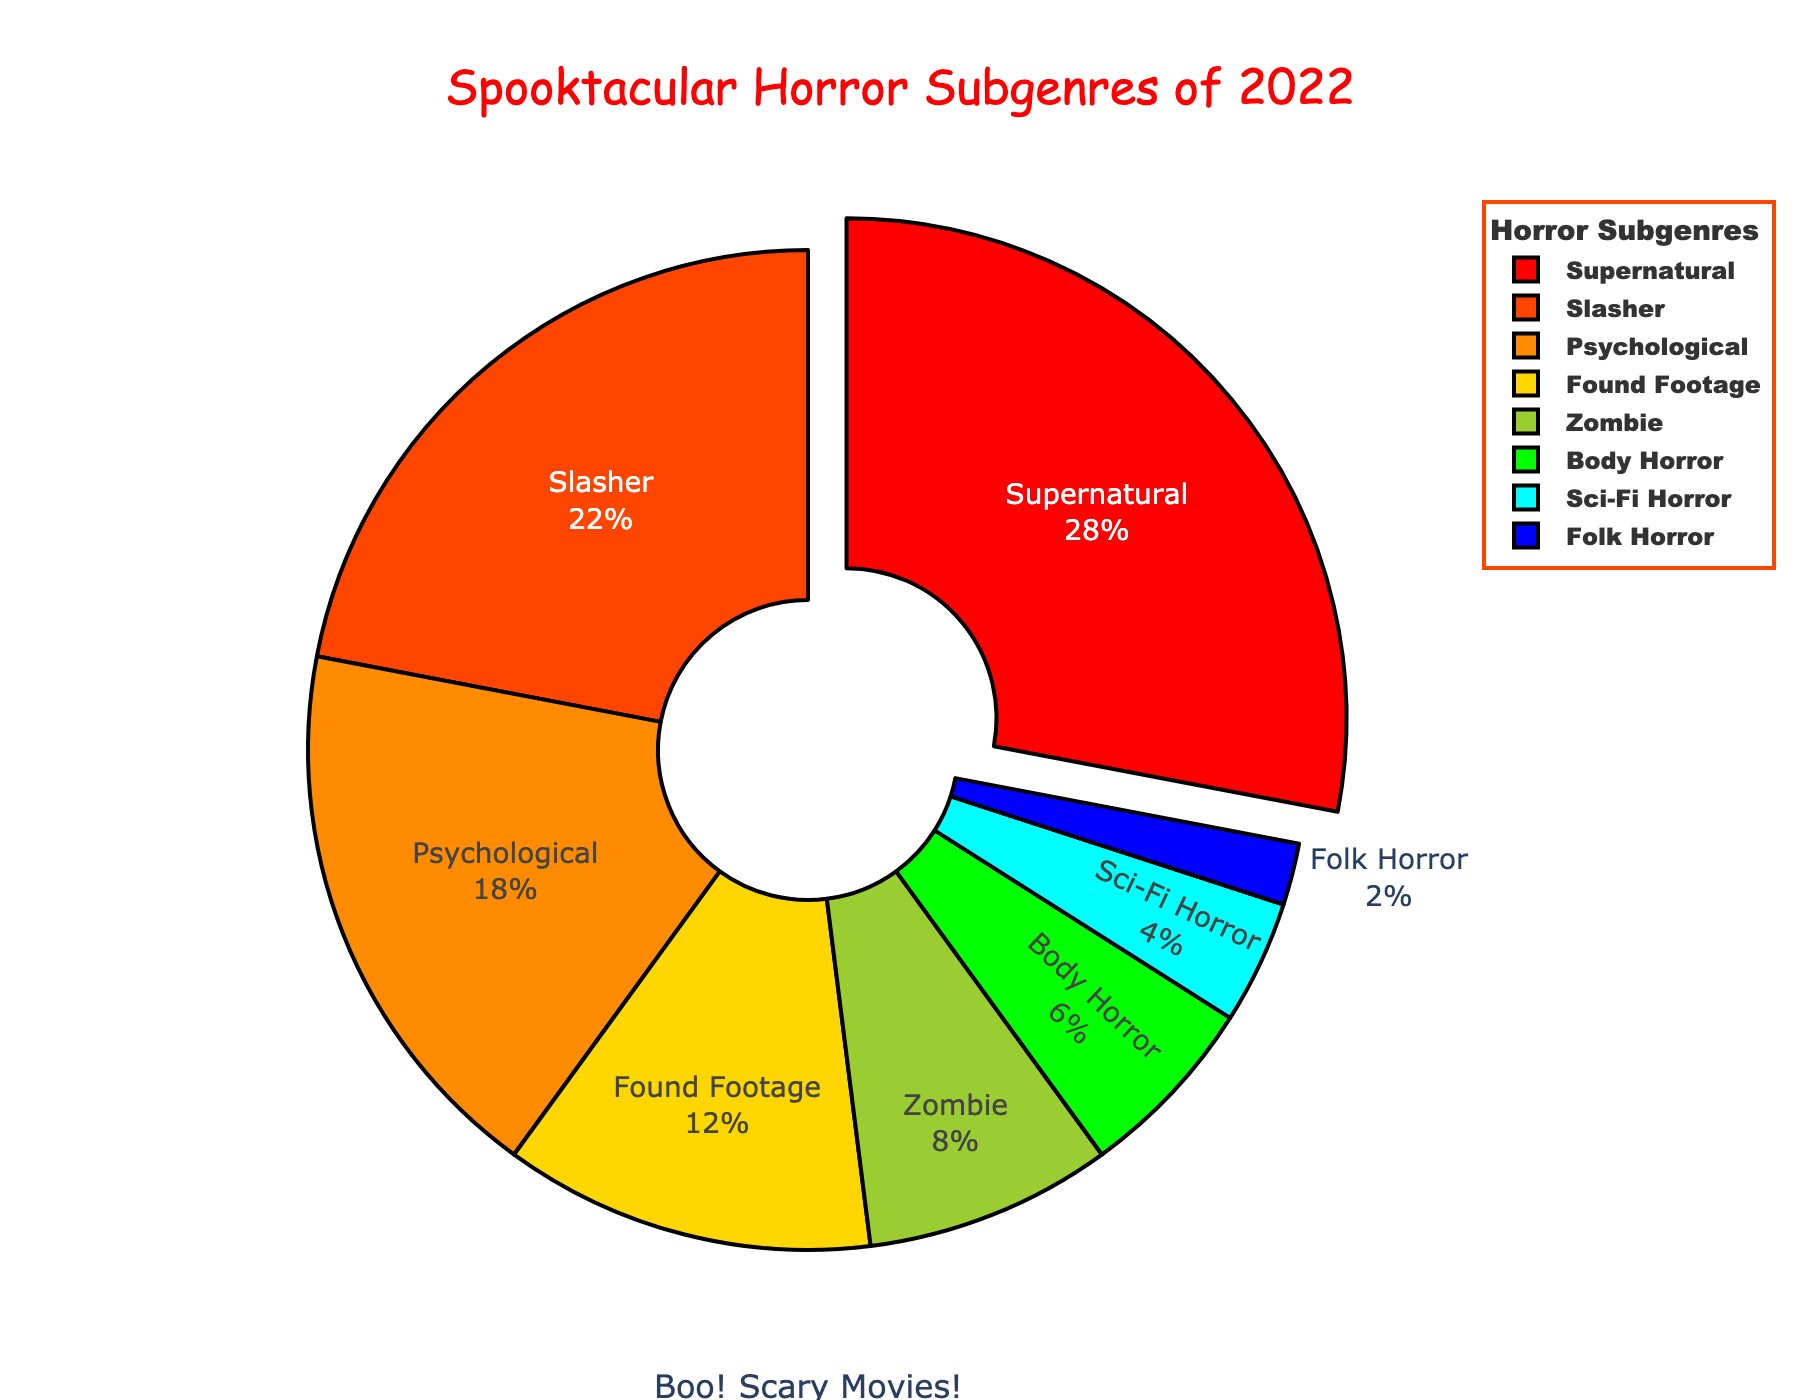What’s the most popular horror subgenre of 2022? The figure shows each subgenre and its corresponding percentage of the total distribution. The subgenre with the highest percentage is the most popular. Supernatural has the highest percentage at 28%.
Answer: Supernatural Which subgenre takes up the smallest percentage of the pie chart? To find the smallest subgenre, look for the segment with the smallest percentage on the chart. Folk Horror has the smallest segment at 2%.
Answer: Folk Horror By how much is the percentage of Supernatural higher than Psychological? Identify the percentages of Supernatural and Psychological subgenres. Then, subtract the percentage of Psychological from that of Supernatural. Supernatural is 28% and Psychological is 18%, so the difference is 28% - 18% = 10%.
Answer: 10% Are there more Slasher or Zombie subgenre movies? Compare the percentage of the Slasher subgenre to that of the Zombie subgenre by checking their respective segments on the pie chart. Slasher is 22% and Zombie is 8%, so Slasher is more.
Answer: Slasher If you combine the percentages of Found Footage and Sci-Fi Horror, what is the total? Add the percentage values of Found Footage and Sci-Fi Horror subgenres together. Found Footage is 12% and Sci-Fi Horror is 4%, so the total is 12% + 4% = 16%.
Answer: 16% Which subgenres combined occupy exactly half of the total distribution? Add the percentages of different combinations of subgenres until the sum equals 50%. Adding Slasher (22%), Found Footage (12%), and Zombie (8%) together results in 42%, which is too little, but adding Body Horror (6%) makes it 22% + 12% + 8% + 6% = 48%. Furthermore, adding Sci-Fi Horror's 4% to this would exceed half. The best-fit answer would involve manual checking: (Supernatural 28% + Slasher 22% or combine smaller segments correctly to sum to 50%).
Answer: Supernatural + Slasher What is the combined percentage of body-related subgenres (Body Horror and Zombie)? Add the percentage values of Body Horror and Zombie subgenres together. Body Horror is 6% and Zombie is 8%, so the total is 6% + 8% = 14%.
Answer: 14% Which subgenre has a percentage closest to being one-third of the total distribution? Calculate one-third of the total distribution, which is approximately 33.33%. Compare this with each subgenre's percentage. Supernatural is closest with 28%.
Answer: Supernatural If you rank the subgenres from highest to lowest percentage, which subgenre comes fourth? Order the subgenres by their percentages in descending order: Supernatural (28%), Slasher (22%), Psychological (18%), Found Footage (12%). The fourth subgenre is Found Footage.
Answer: Found Footage Which colored segment represents the Zombie subgenre? Find the color associated with the segment labeled “Zombie.” Zombie is shown with the light green segment in the pie chart.
Answer: Light Green 